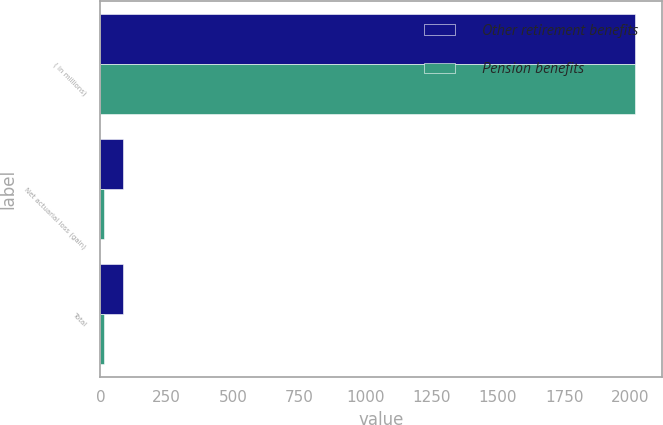<chart> <loc_0><loc_0><loc_500><loc_500><stacked_bar_chart><ecel><fcel>( in millions)<fcel>Net actuarial loss (gain)<fcel>Total<nl><fcel>Other retirement benefits<fcel>2016<fcel>86<fcel>83.7<nl><fcel>Pension benefits<fcel>2016<fcel>11.9<fcel>14.9<nl></chart> 